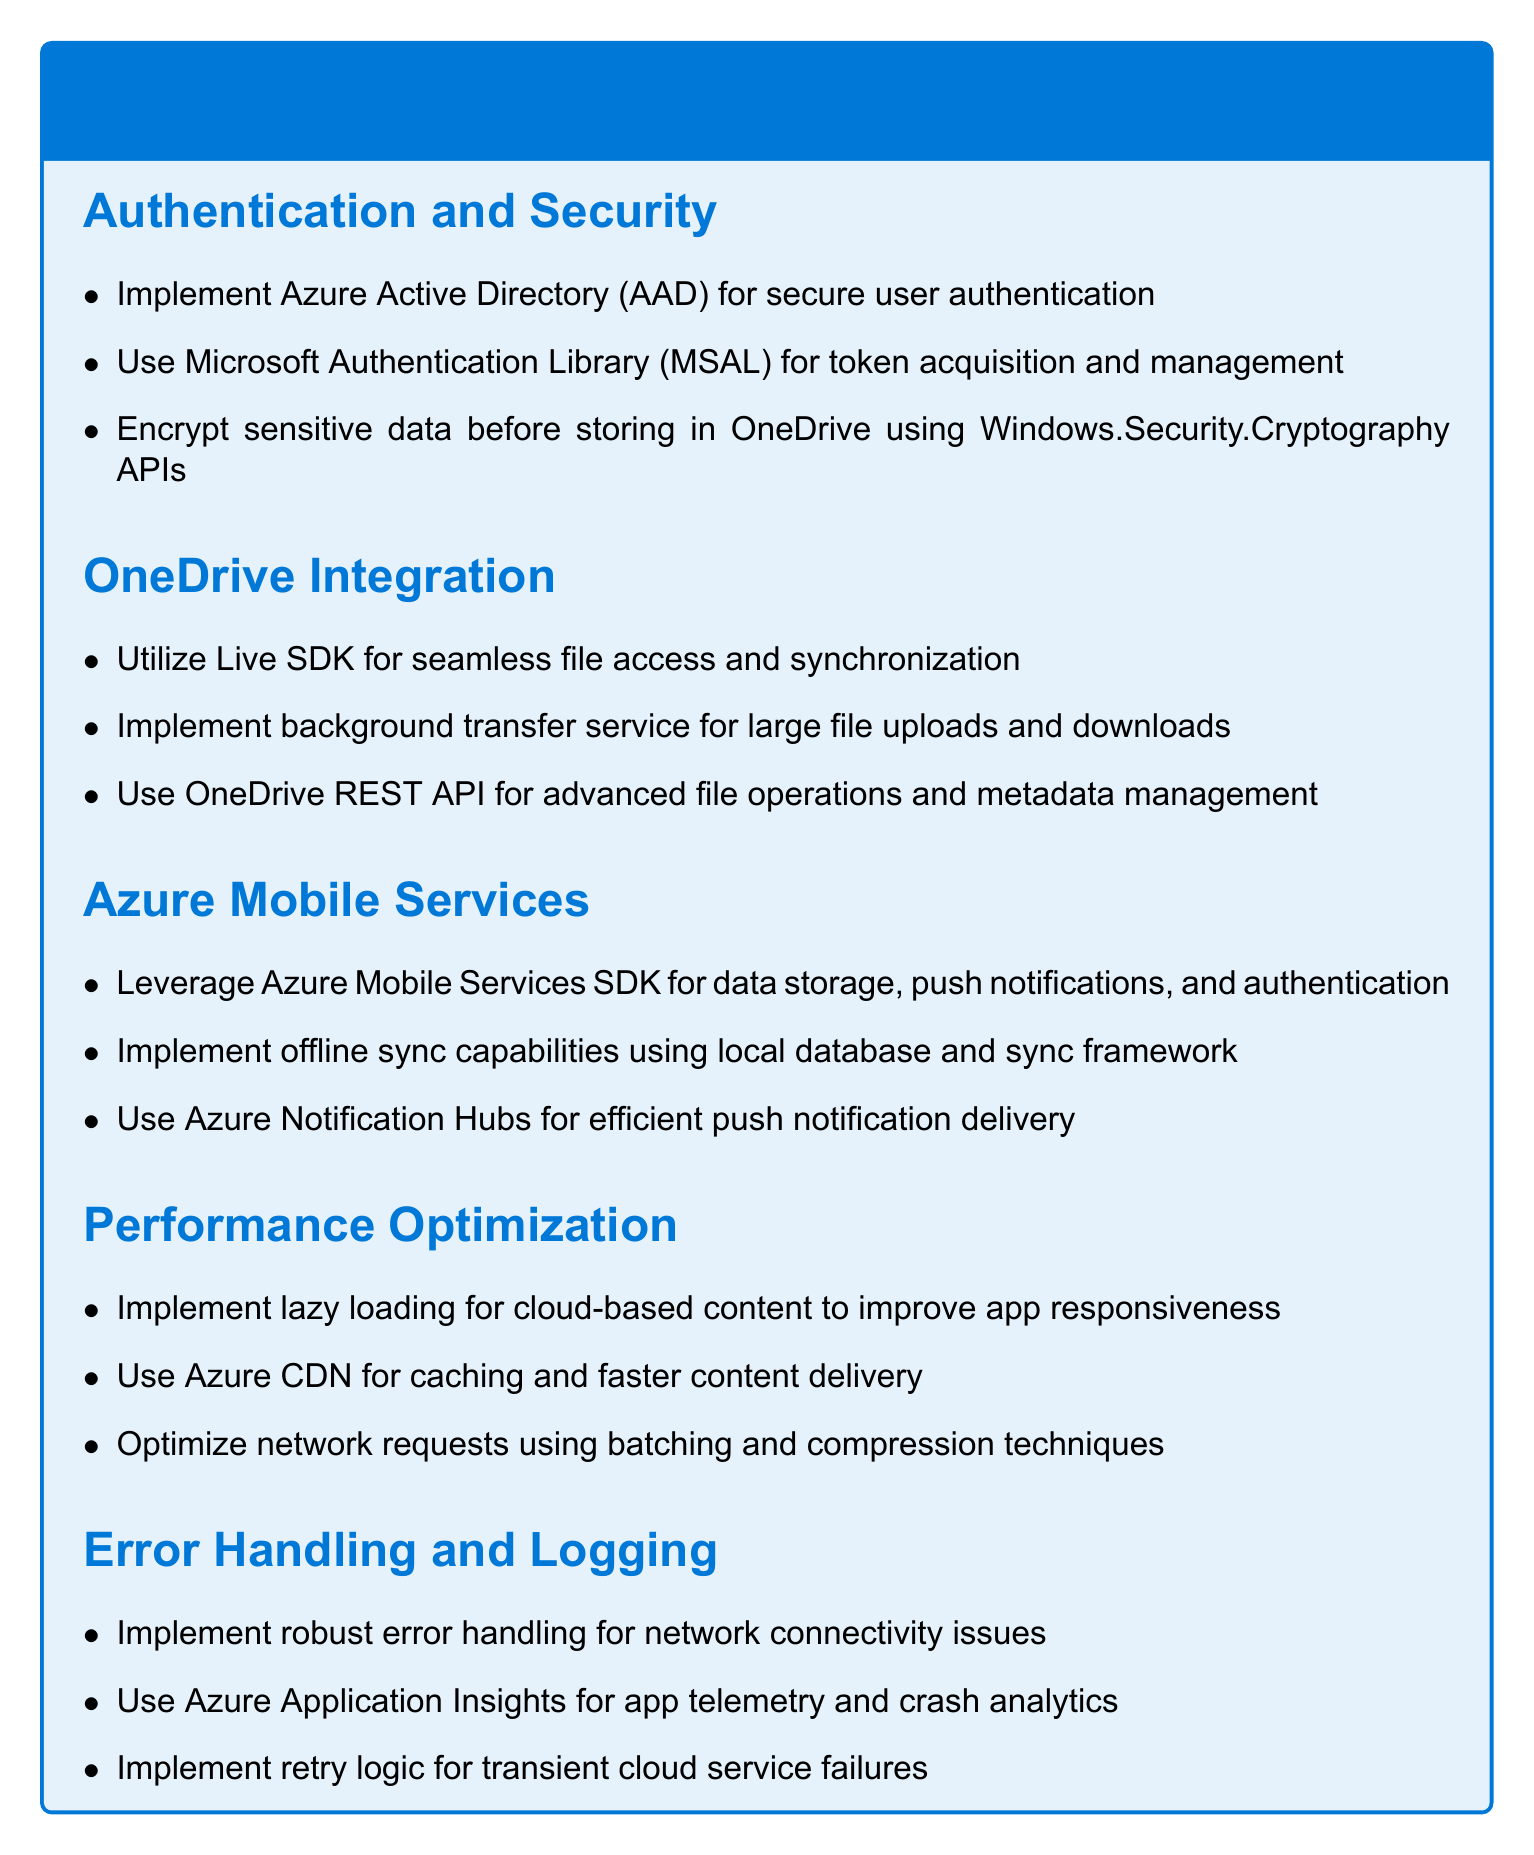What is the recommended tool for user authentication? The document suggests implementing Azure Active Directory for secure user authentication.
Answer: Azure Active Directory Which library is suggested for token acquisition? The Microsoft Authentication Library (MSAL) is mentioned for token acquisition and management.
Answer: Microsoft Authentication Library What service should be used for large file uploads and downloads? The document recommends implementing a background transfer service for large file uploads and downloads.
Answer: Background transfer service What is one of the main functionalities of Azure Notification Hubs? Azure Notification Hubs is used for efficient push notification delivery as stated in the Azure Mobile Services section.
Answer: Efficient push notification delivery What technique is recommended to improve app responsiveness? Implementing lazy loading for cloud-based content is recommended to improve app responsiveness.
Answer: Lazy loading What is the purpose of Azure Application Insights? Azure Application Insights is used for app telemetry and crash analytics according to the Error Handling and Logging section.
Answer: App telemetry and crash analytics Which API should be used for advanced file operations? The OneDrive REST API is suggested for advanced file operations and metadata management.
Answer: OneDrive REST API What should be done before storing sensitive data in OneDrive? The document states that sensitive data should be encrypted before storing in OneDrive.
Answer: Encrypt sensitive data What is recommended to optimize network requests? Using batching and compression techniques is recommended to optimize network requests.
Answer: Batching and compression techniques 